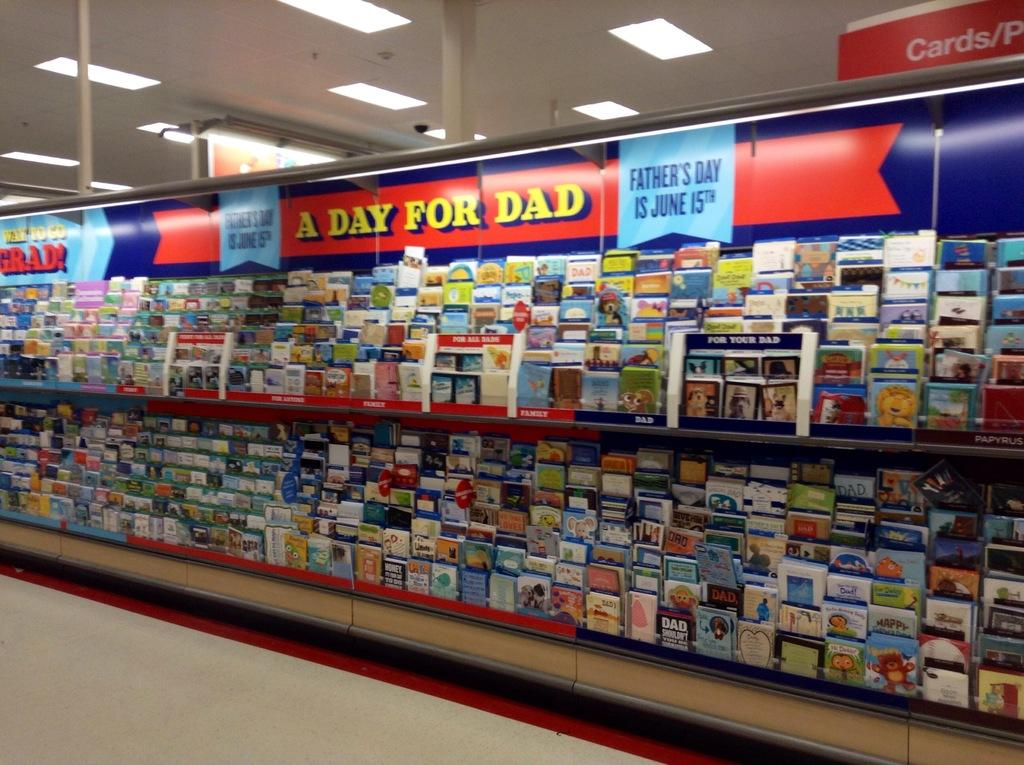<image>
Share a concise interpretation of the image provided. Section in a store selling cards with a sign saying "A Day For Dad". 